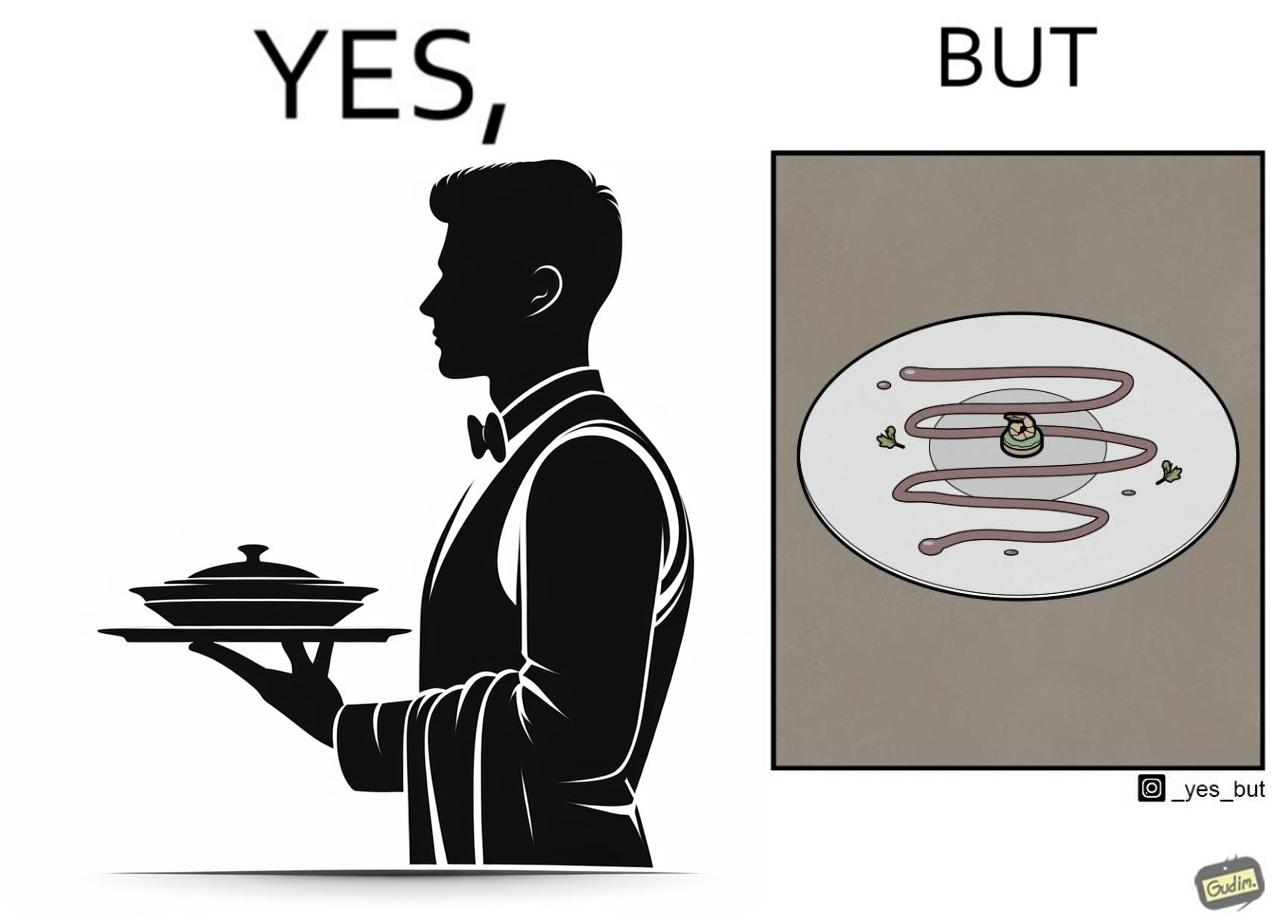What makes this image funny or satirical? The image is ironic, because  in the first image the waiter is bringing the dish to the table presenting it as some lavish dish but in the second image when the dish is shown in the plate its just a small piece to eat 